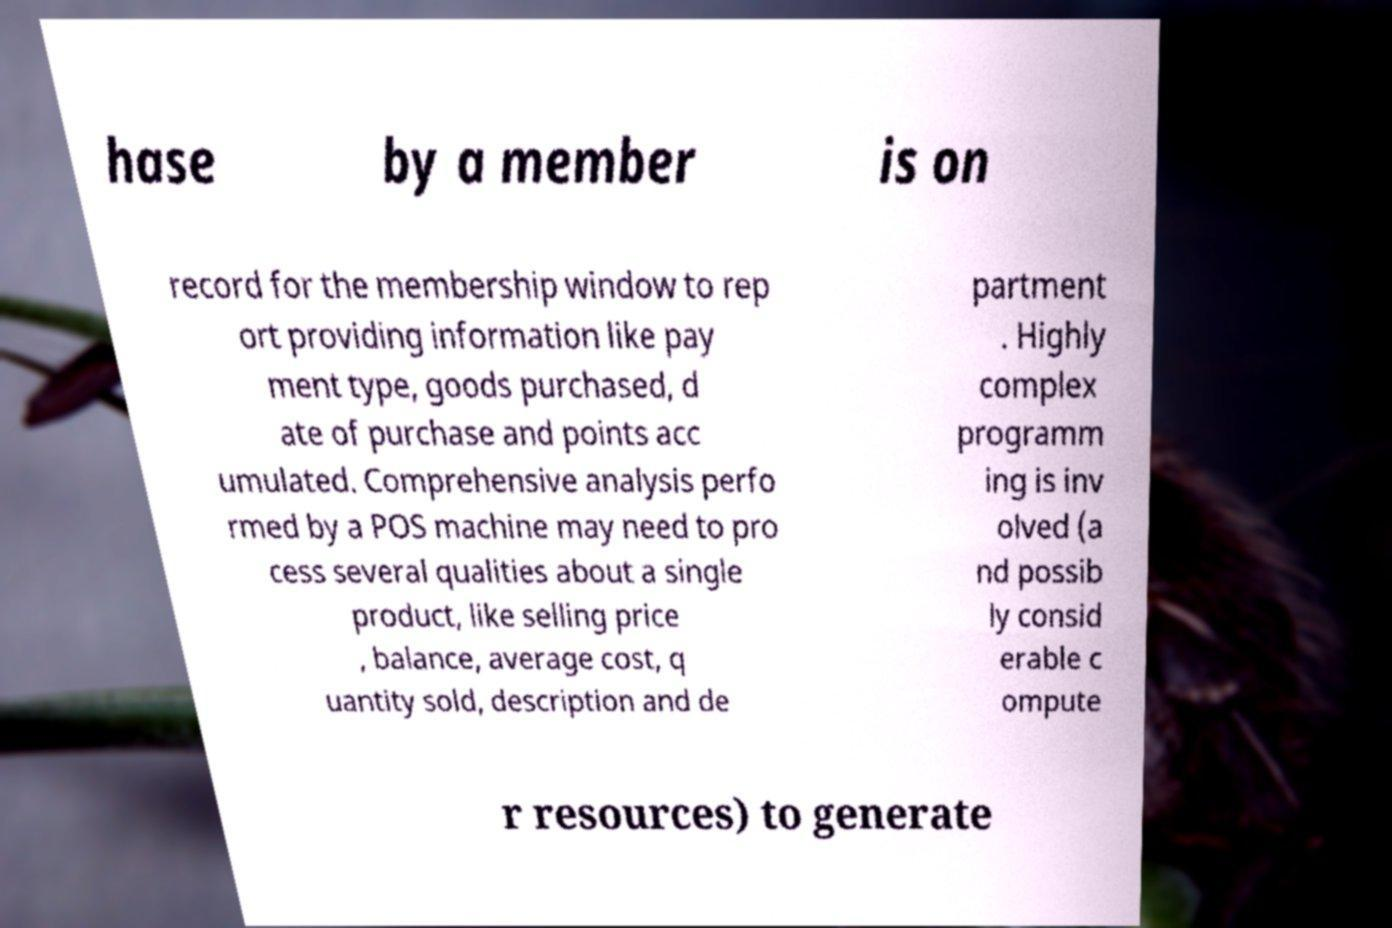Can you read and provide the text displayed in the image?This photo seems to have some interesting text. Can you extract and type it out for me? hase by a member is on record for the membership window to rep ort providing information like pay ment type, goods purchased, d ate of purchase and points acc umulated. Comprehensive analysis perfo rmed by a POS machine may need to pro cess several qualities about a single product, like selling price , balance, average cost, q uantity sold, description and de partment . Highly complex programm ing is inv olved (a nd possib ly consid erable c ompute r resources) to generate 